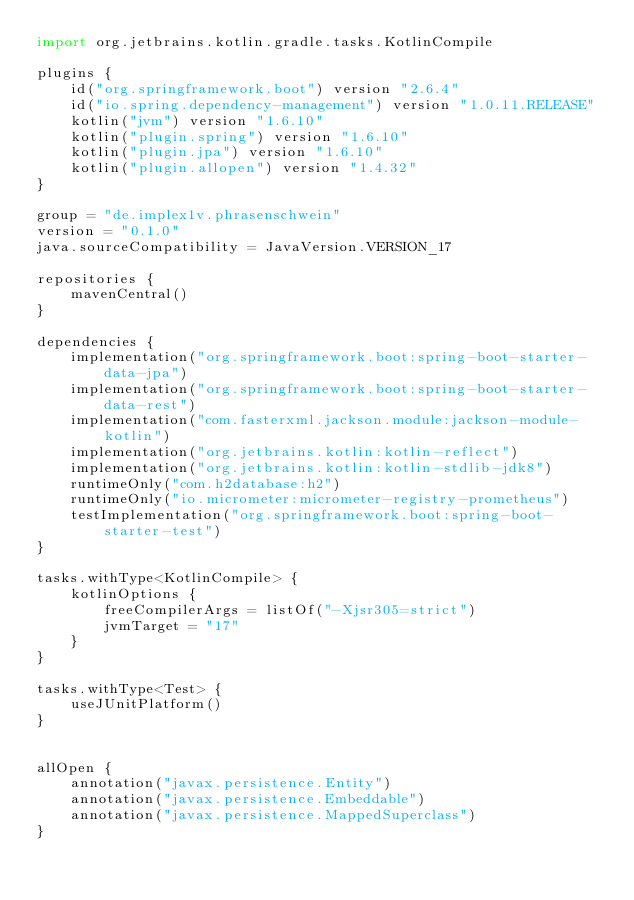Convert code to text. <code><loc_0><loc_0><loc_500><loc_500><_Kotlin_>import org.jetbrains.kotlin.gradle.tasks.KotlinCompile

plugins {
	id("org.springframework.boot") version "2.6.4"
	id("io.spring.dependency-management") version "1.0.11.RELEASE"
	kotlin("jvm") version "1.6.10"
	kotlin("plugin.spring") version "1.6.10"
	kotlin("plugin.jpa") version "1.6.10"
	kotlin("plugin.allopen") version "1.4.32"
}

group = "de.implex1v.phrasenschwein"
version = "0.1.0"
java.sourceCompatibility = JavaVersion.VERSION_17

repositories {
	mavenCentral()
}

dependencies {
	implementation("org.springframework.boot:spring-boot-starter-data-jpa")
	implementation("org.springframework.boot:spring-boot-starter-data-rest")
	implementation("com.fasterxml.jackson.module:jackson-module-kotlin")
	implementation("org.jetbrains.kotlin:kotlin-reflect")
	implementation("org.jetbrains.kotlin:kotlin-stdlib-jdk8")
	runtimeOnly("com.h2database:h2")
	runtimeOnly("io.micrometer:micrometer-registry-prometheus")
	testImplementation("org.springframework.boot:spring-boot-starter-test")
}

tasks.withType<KotlinCompile> {
	kotlinOptions {
		freeCompilerArgs = listOf("-Xjsr305=strict")
		jvmTarget = "17"
	}
}

tasks.withType<Test> {
	useJUnitPlatform()
}


allOpen {
	annotation("javax.persistence.Entity")
	annotation("javax.persistence.Embeddable")
	annotation("javax.persistence.MappedSuperclass")
}</code> 